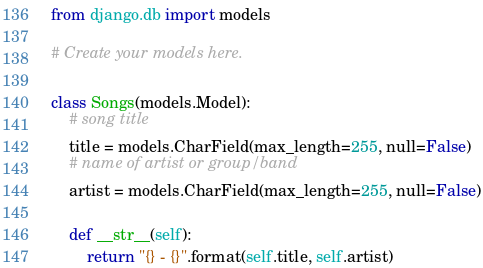<code> <loc_0><loc_0><loc_500><loc_500><_Python_>from django.db import models

# Create your models here.

class Songs(models.Model):
    # song title
    title = models.CharField(max_length=255, null=False)
    # name of artist or group/band
    artist = models.CharField(max_length=255, null=False)

    def __str__(self):
        return "{} - {}".format(self.title, self.artist)
</code> 